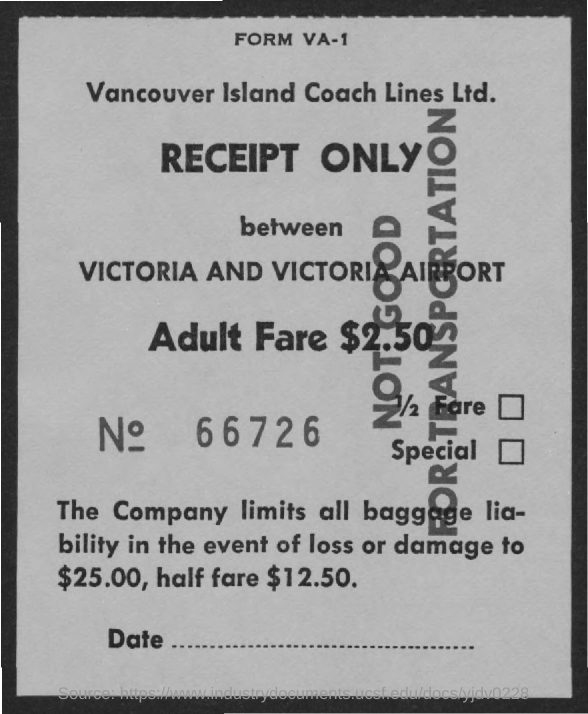Mention a couple of crucial points in this snapshot. Adult fare is $2.50. The receipt was issued by Vancouver Island Coach Lines Ltd. This receipt number is 66726. 